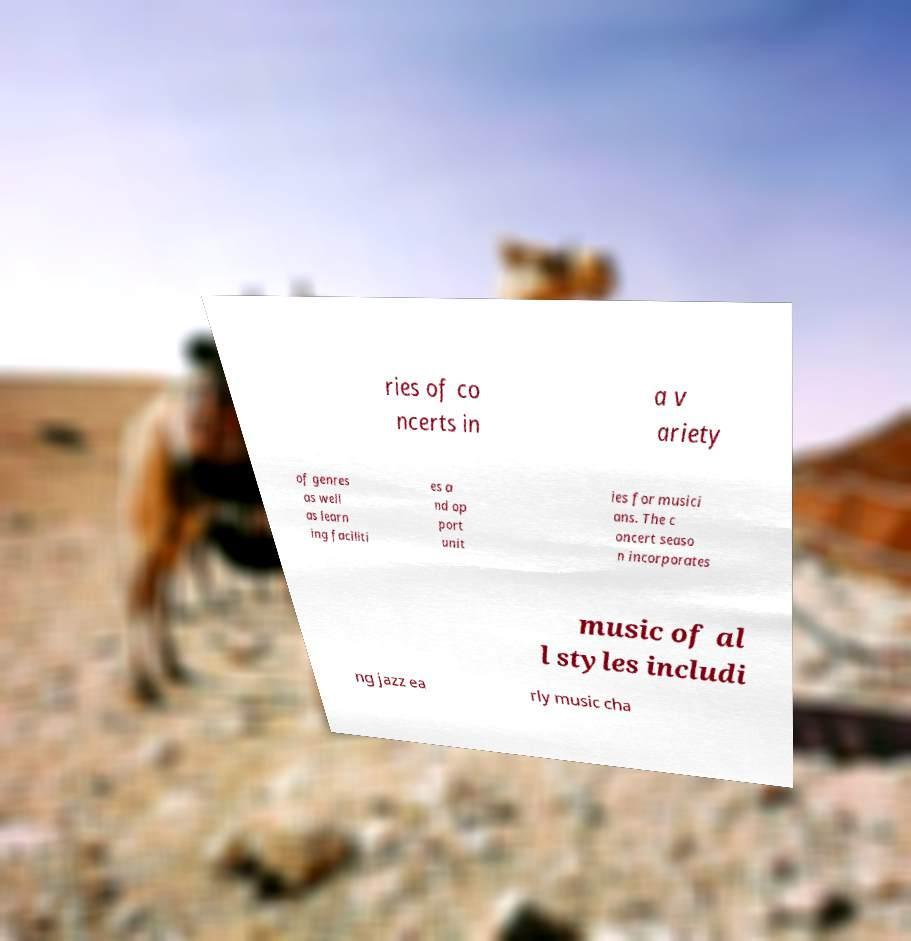Can you accurately transcribe the text from the provided image for me? ries of co ncerts in a v ariety of genres as well as learn ing faciliti es a nd op port unit ies for musici ans. The c oncert seaso n incorporates music of al l styles includi ng jazz ea rly music cha 